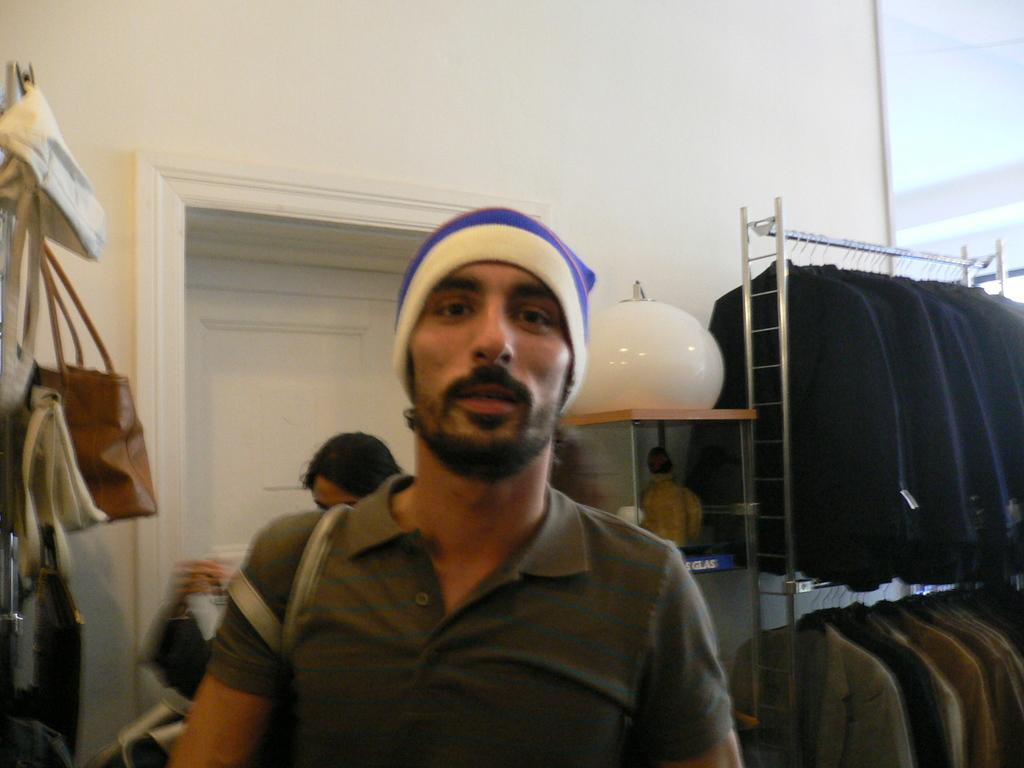What can be seen in the image? There is a person in the image. Can you describe the person's attire? The person is wearing a cap. What else can be seen in the background of the image? There is a woman, bags, a wall, and clothes hanged on a hanger in the background of the image. What type of lock is used to secure the actor's dressing room in the image? There is no actor or dressing room present in the image, so it is not possible to determine what type of lock might be used. 